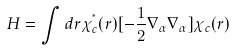<formula> <loc_0><loc_0><loc_500><loc_500>H = \int d { r } \chi ^ { ^ { * } } _ { c } ( { r } ) [ - \frac { 1 } { 2 } \nabla _ { \alpha } \nabla _ { \alpha } ] \chi _ { c } ( { r } )</formula> 